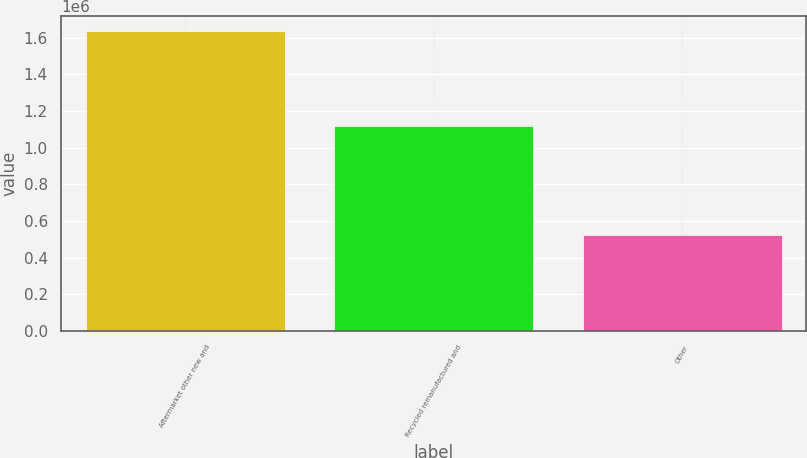Convert chart to OTSL. <chart><loc_0><loc_0><loc_500><loc_500><bar_chart><fcel>Aftermarket other new and<fcel>Recycled remanufactured and<fcel>Other<nl><fcel>1.634e+06<fcel>1.11509e+06<fcel>520771<nl></chart> 